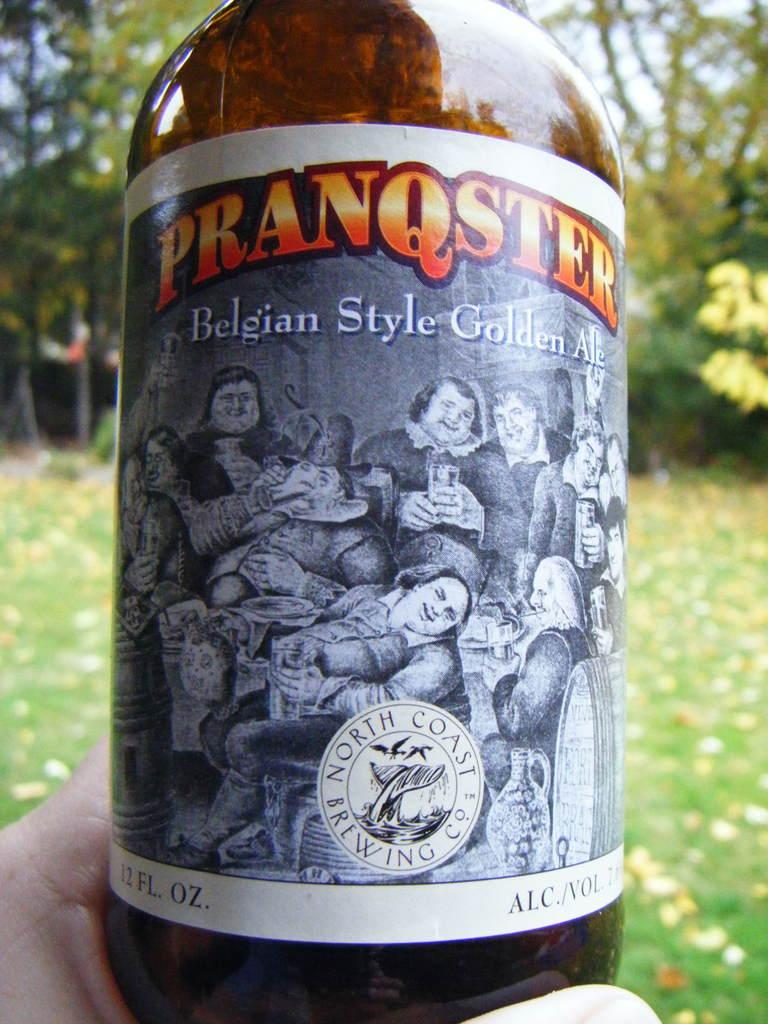<image>
Write a terse but informative summary of the picture. A bottle of pranqster photographed in the hand of someone outside. 